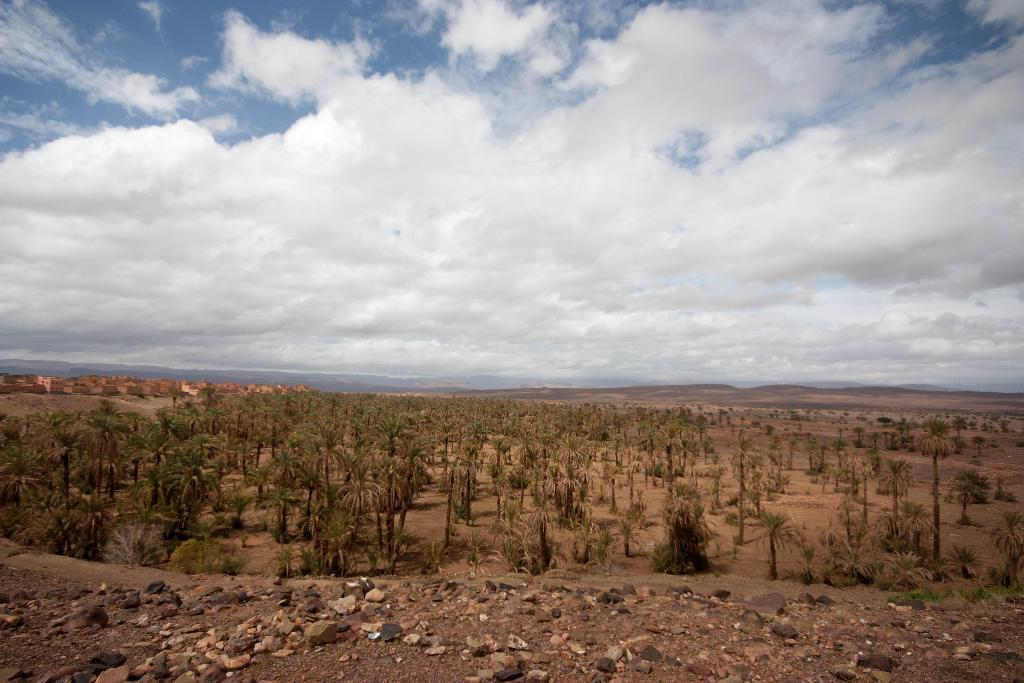What type of vegetation can be seen in the image? There are trees in the image. What can be seen in the distance in the image? There are hills visible in the background of the image. What is visible above the trees and hills in the image? The sky is visible in the background of the image. What type of terrain is present at the bottom of the image? There are rocks at the bottom of the image. Can you see a needle being used for teaching in the image? There is no needle or teaching activity present in the image. What type of straw is growing among the rocks in the image? There are no straws present in the image; it features trees, hills, rocks, and the sky. 